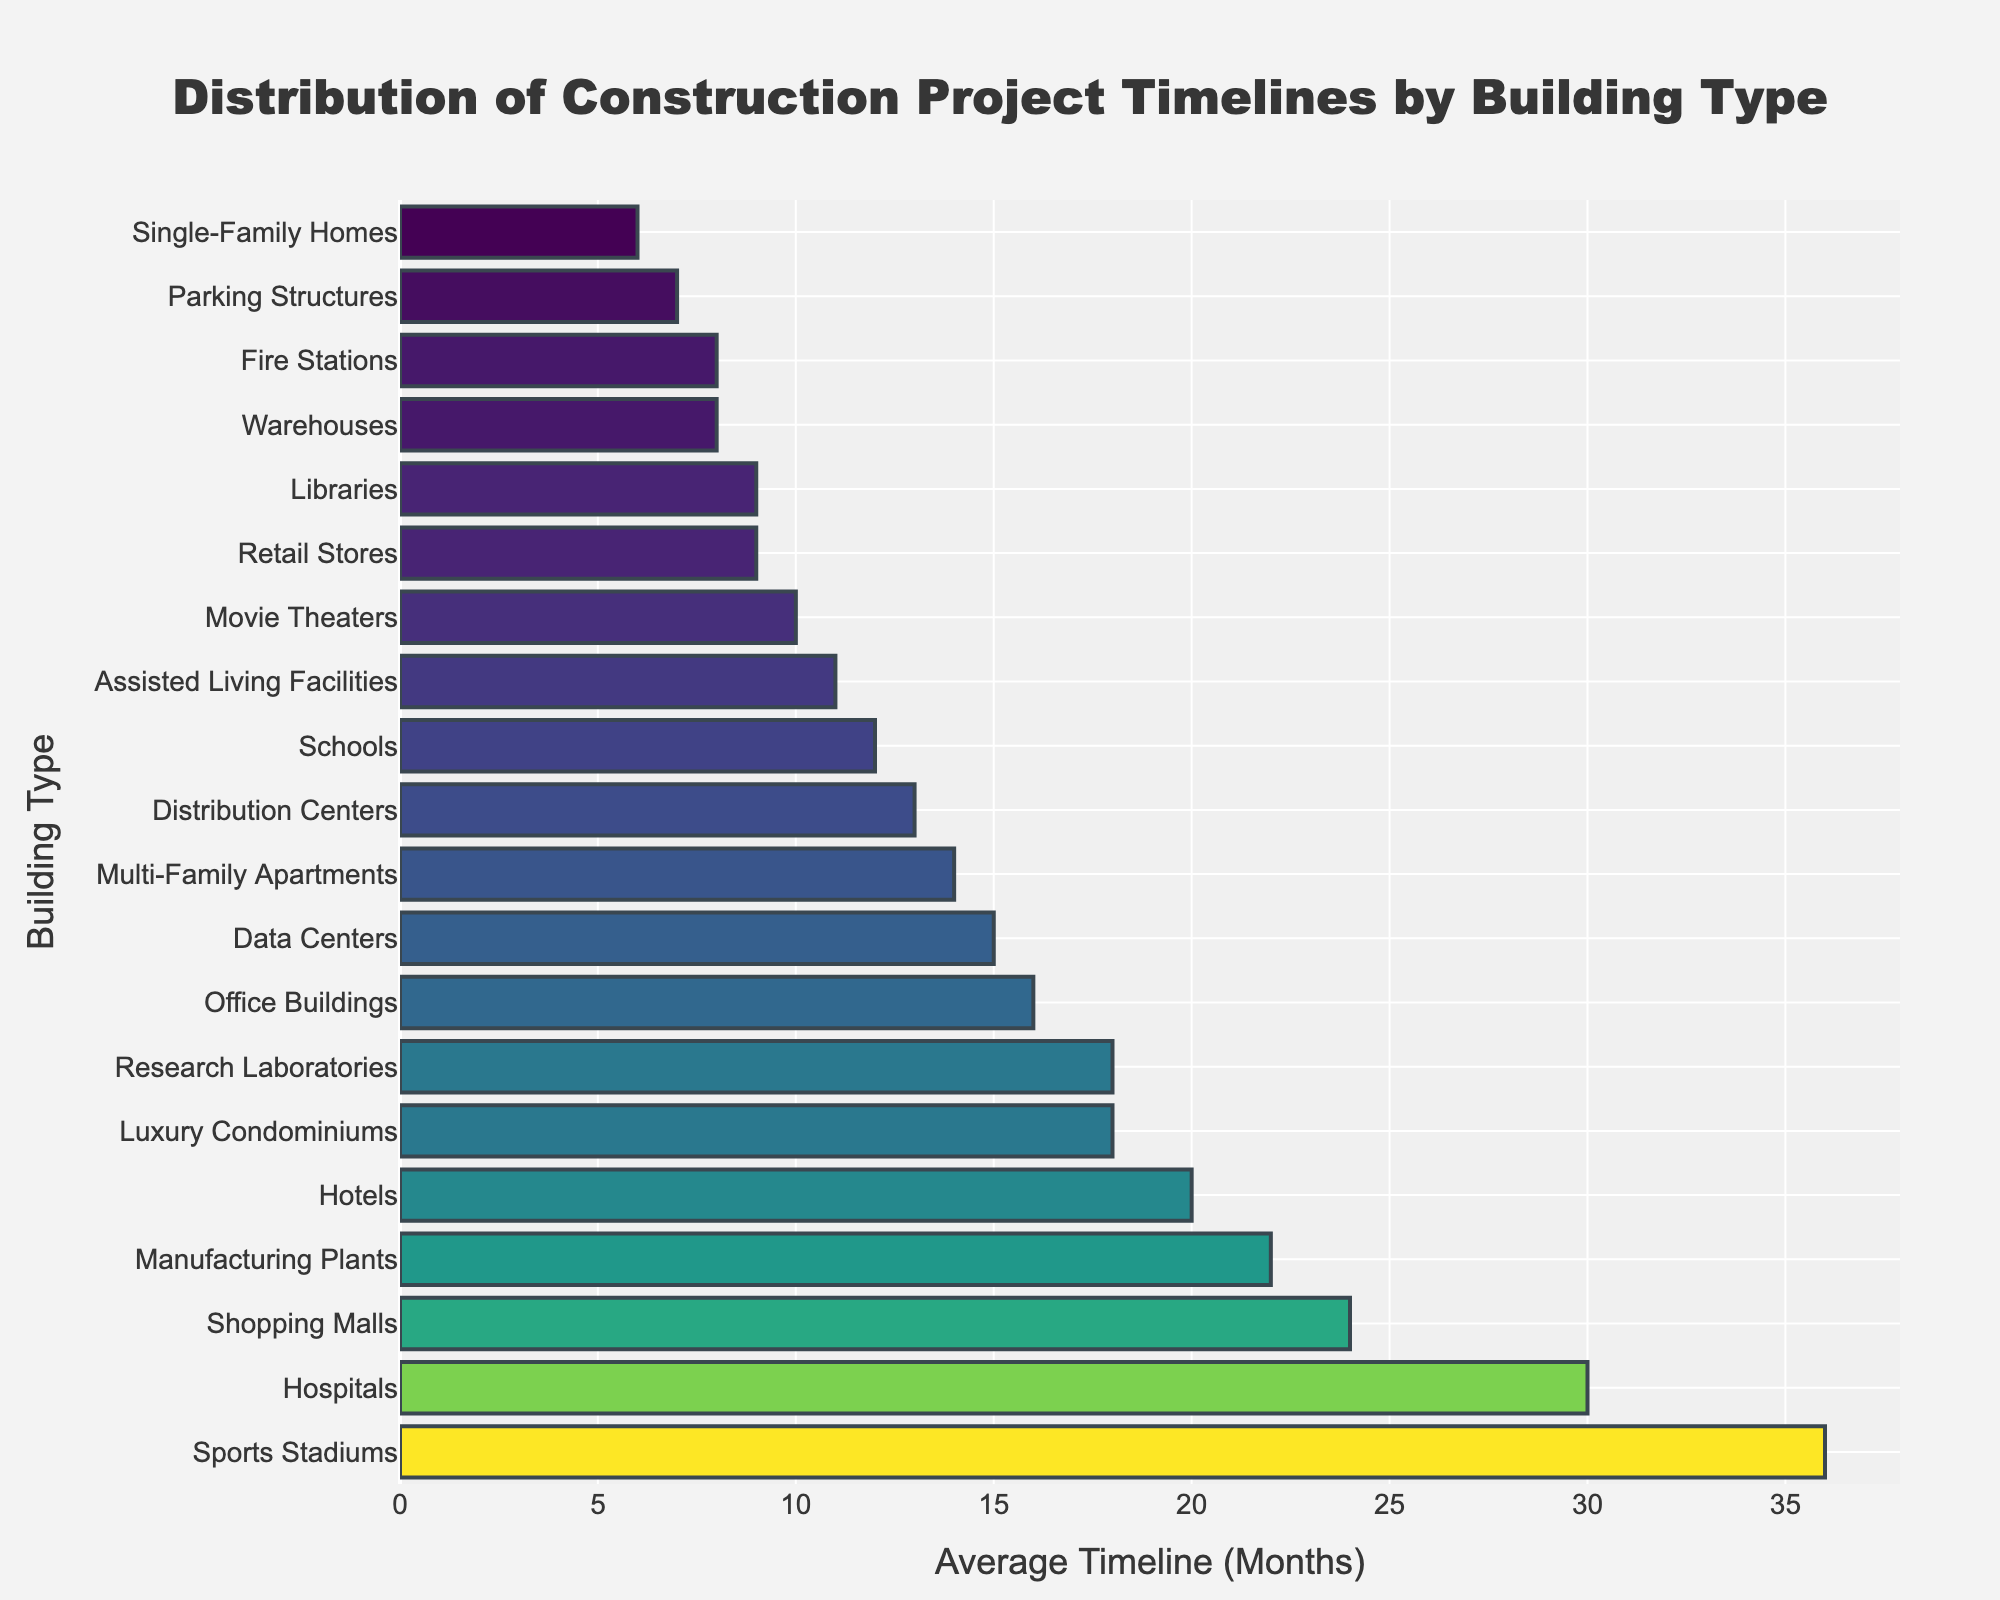Which building type has the longest average construction timeline? The bar chart indicates that Sports Stadiums have the longest bar, representing the highest value on the horizontal axis.
Answer: Sports Stadiums Which building type has a shorter timeline: Libraries or Manufacturing Plants? By comparing the lengths of the bars for Libraries and Manufacturing Plants, Libraries have a shorter bar, indicating a shorter timeline.
Answer: Libraries Is the average timeline for constructing Hospitals greater than 20 months? The horizontal bar for Hospitals extends up to 30 months, which is more than 20 months.
Answer: Yes Which building type has the shortest construction timeline and what is it? The shortest bar belongs to Single-Family Homes, extending only to 6 months.
Answer: Single-Family Homes, 6 months What is the difference in average construction timelines between Office Buildings and Parking Structures? Office Buildings have an average timeline of 16 months, and Parking Structures have 7 months. The difference is 16 - 7 = 9 months.
Answer: 9 months Which building types have an average construction timeline of exactly 18 months? The bars for Luxury Condominiums and Research Laboratories both extend to 18 months.
Answer: Luxury Condominiums, Research Laboratories How does the average construction timeline for Shopping Malls compare to Data Centers? Shopping Malls have a timeline of 24 months, while Data Centers have 15 months. Shopping Malls have a longer timeline.
Answer: Shopping Malls have a longer timeline If you combine the timeliness of constructing Retail Stores and Schools, what is the total duration? Retail Stores have an average timeline of 9 months, and Schools have 12 months. Combined, it's 9 + 12 = 21 months.
Answer: 21 months Are there more projects with timelines less than 10 months or more than 20 months? Projects with timelines < 10 months: Single-Family Homes (6), Parking Structures (7), Warehouses (8), Fire Stations (8), Libraries (9), Retail Stores (9). Total = 6. Projects with timelines > 20 months: Shopping Malls (24), Hospitals (30), Hotels (20), Manufacturing Plants (22), Sports Stadiums (36). Total = 5.
Answer: Less than 10 months Which building type has a timeline that is closest to the average of Office Buildings and Assisted Living Facilities? Office Buildings have 16 months and Assisted Living Facilities have 11 months. Average = (16 + 11) / 2 = 13.5 months. Distribution Centers have a timeline of 13 months, closest to 13.5.
Answer: Distribution Centers 